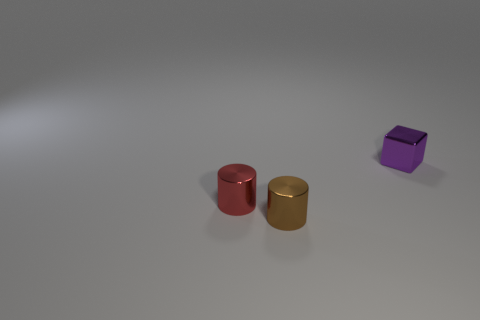There is a shiny object behind the small cylinder left of the cylinder that is in front of the red shiny object; what shape is it?
Keep it short and to the point. Cube. There is a tiny metallic cylinder in front of the small red object; is it the same color as the object behind the tiny red metallic cylinder?
Offer a terse response. No. Are there fewer tiny purple things that are in front of the tiny red shiny cylinder than tiny purple metallic things behind the tiny metal block?
Offer a very short reply. No. Is there anything else that is the same shape as the purple shiny object?
Keep it short and to the point. No. There is another object that is the same shape as the tiny red object; what color is it?
Your response must be concise. Brown. Does the brown metal object have the same shape as the small metallic thing that is on the right side of the small brown object?
Provide a short and direct response. No. What number of objects are shiny cylinders that are to the right of the tiny red metallic object or shiny things that are in front of the cube?
Keep it short and to the point. 2. What is the material of the brown cylinder?
Make the answer very short. Metal. How many other things are the same size as the brown thing?
Give a very brief answer. 2. What size is the thing behind the red thing?
Make the answer very short. Small. 